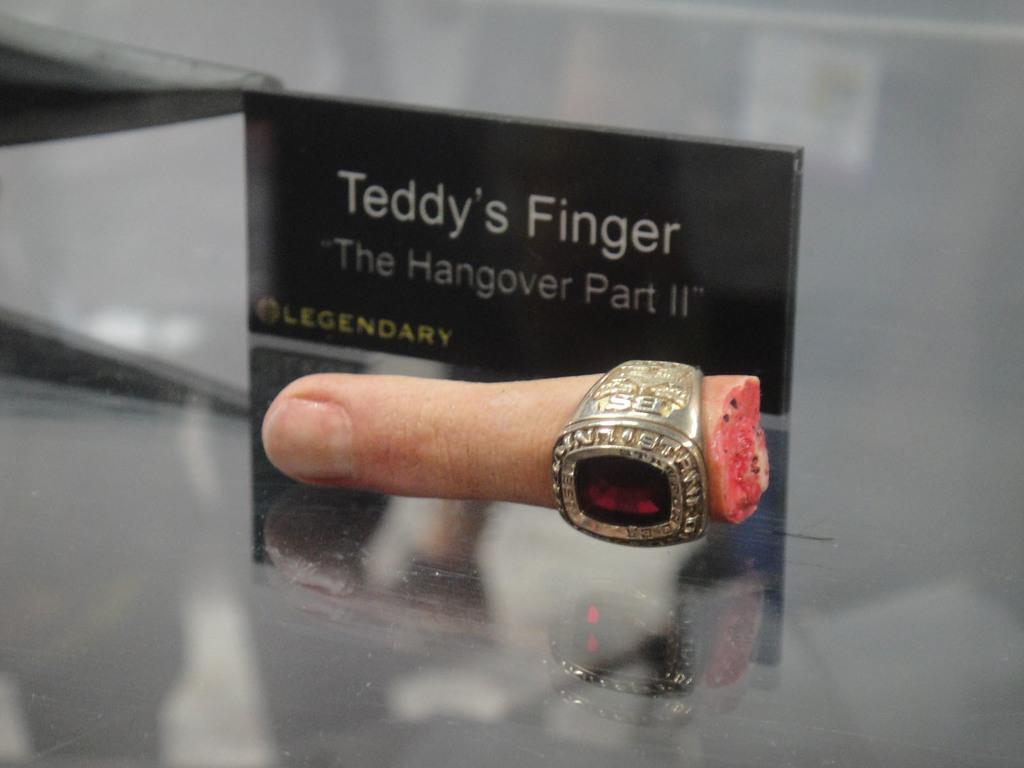What can be seen on a finger in the image? There is a ring on a finger in the image. What is written on an object in the background? Something is written on a black object in the background. Where are the objects located in the image? The objects are on a surface. What type of fuel is being used by the bridge in the image? There is no bridge present in the image, so it is not possible to determine what type of fuel might be used. 